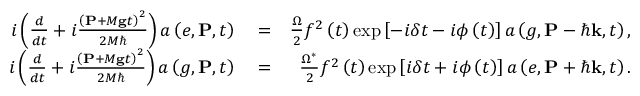Convert formula to latex. <formula><loc_0><loc_0><loc_500><loc_500>\begin{array} { r l r } { i \left ( \frac { d } { d t } + i \frac { \left ( P + M g t \right ) ^ { 2 } } { 2 M } \right ) a \left ( e , P , t \right ) } & = } & { \frac { \Omega } { 2 } f ^ { 2 } \left ( t \right ) \exp \left [ - i \delta t - i \phi \left ( t \right ) \right ] a \left ( g , P - \hbar { k } , t \right ) , } \\ { i \left ( \frac { d } { d t } + i \frac { \left ( P + M g t \right ) ^ { 2 } } { 2 M } \right ) a \left ( g , P , t \right ) } & = } & { \frac { \Omega ^ { \ast } } { 2 } f ^ { 2 } \left ( t \right ) \exp \left [ i \delta t + i \phi \left ( t \right ) \right ] a \left ( e , P + \hbar { k } , t \right ) . } \end{array}</formula> 